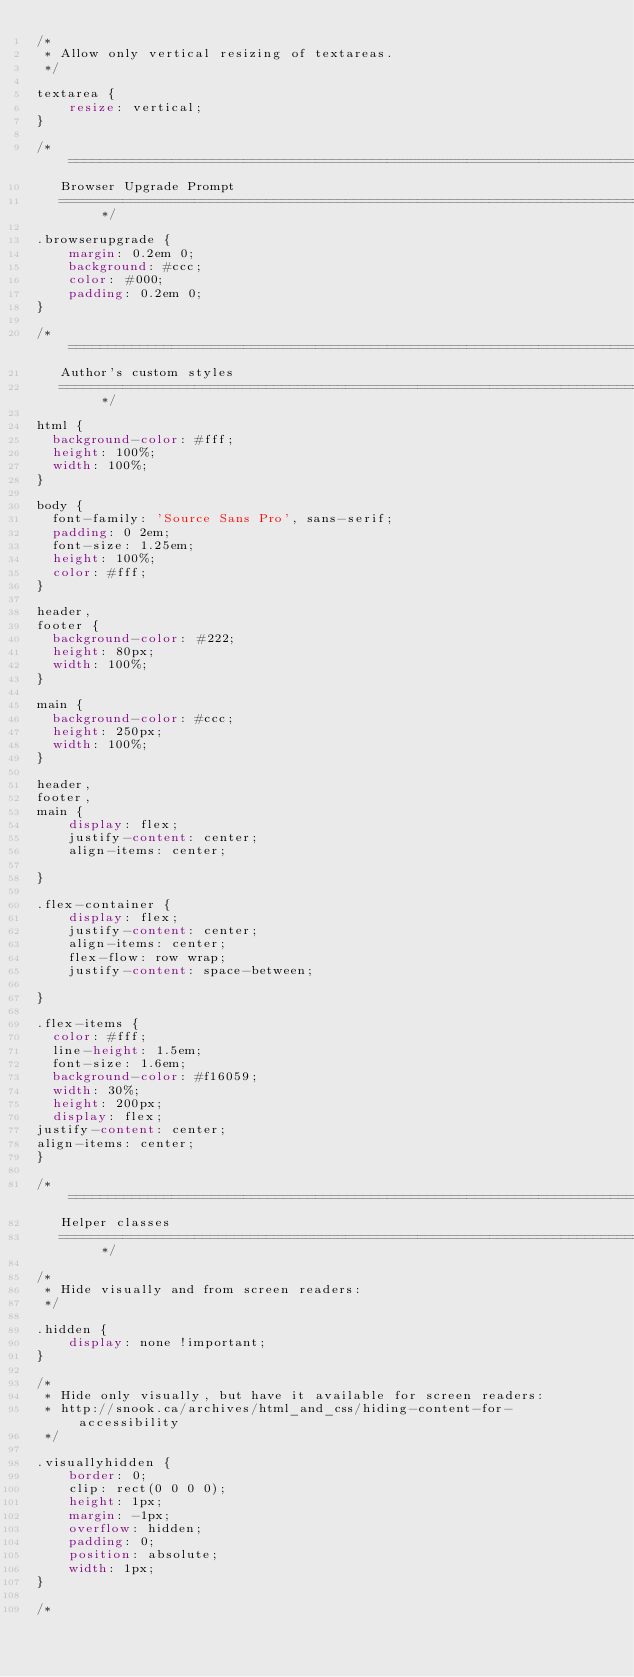Convert code to text. <code><loc_0><loc_0><loc_500><loc_500><_CSS_>/*
 * Allow only vertical resizing of textareas.
 */

textarea {
    resize: vertical;
}

/* ==========================================================================
   Browser Upgrade Prompt
   ========================================================================== */

.browserupgrade {
    margin: 0.2em 0;
    background: #ccc;
    color: #000;
    padding: 0.2em 0;
}

/* ==========================================================================
   Author's custom styles
   ========================================================================== */

html {
  background-color: #fff;
  height: 100%;
  width: 100%;
}

body {
  font-family: 'Source Sans Pro', sans-serif;
  padding: 0 2em;
  font-size: 1.25em;
  height: 100%;
  color: #fff;
}

header,
footer {
  background-color: #222;
  height: 80px;
  width: 100%;
}

main {
  background-color: #ccc;
  height: 250px;
  width: 100%;
}

header,
footer,
main {
    display: flex;
    justify-content: center;
    align-items: center;

}

.flex-container {
    display: flex;
    justify-content: center;
    align-items: center;
    flex-flow: row wrap;
    justify-content: space-between;

}

.flex-items {
  color: #fff;
  line-height: 1.5em;
  font-size: 1.6em;
  background-color: #f16059;
  width: 30%;
  height: 200px;
  display: flex;
justify-content: center;
align-items: center;
}

/* ==========================================================================
   Helper classes
   ========================================================================== */

/*
 * Hide visually and from screen readers:
 */

.hidden {
    display: none !important;
}

/*
 * Hide only visually, but have it available for screen readers:
 * http://snook.ca/archives/html_and_css/hiding-content-for-accessibility
 */

.visuallyhidden {
    border: 0;
    clip: rect(0 0 0 0);
    height: 1px;
    margin: -1px;
    overflow: hidden;
    padding: 0;
    position: absolute;
    width: 1px;
}

/*</code> 